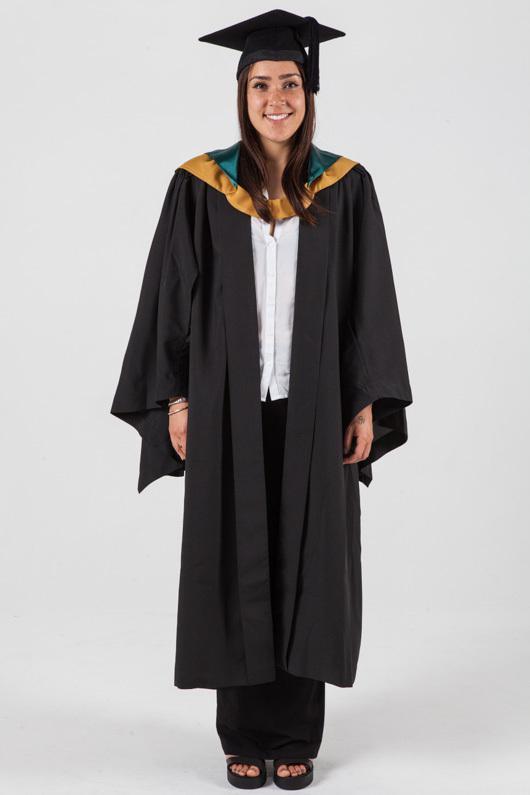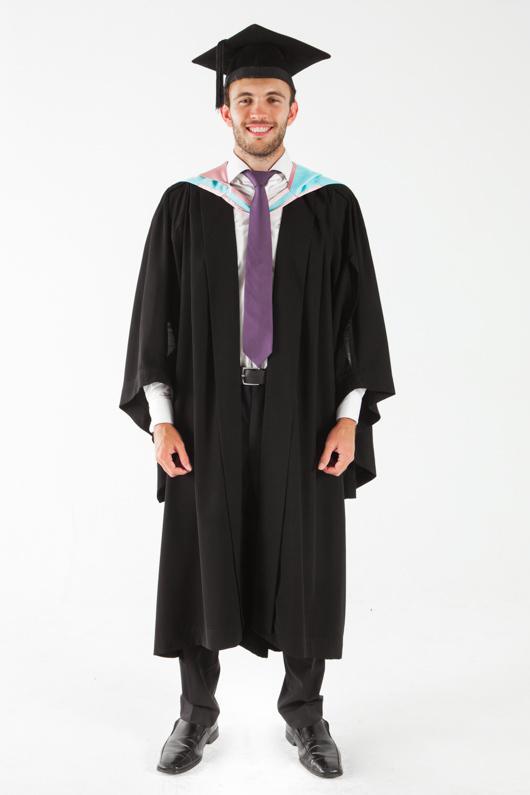The first image is the image on the left, the second image is the image on the right. Examine the images to the left and right. Is the description "Two people are dressed in a blue graduation cap and blue graduation gown" accurate? Answer yes or no. No. The first image is the image on the left, the second image is the image on the right. Analyze the images presented: Is the assertion "A young girl wears a blue graduation robe and cap in one image." valid? Answer yes or no. No. 